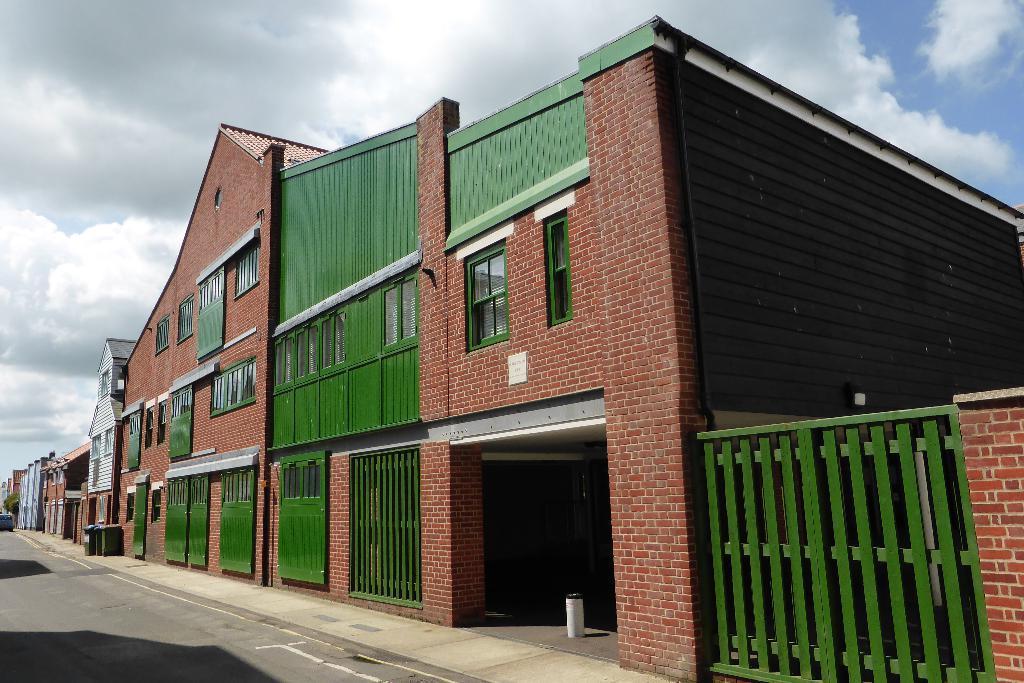In one or two sentences, can you explain what this image depicts? This picture is clicked outside. On the right we can see a house and we can see the green color windows, doors and a gate of the house. In the background we can see the sky which is full of clouds and we can see the houses, vehicle and some other objects. 